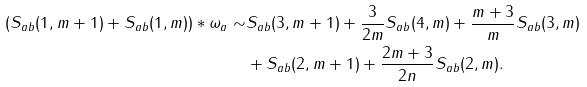<formula> <loc_0><loc_0><loc_500><loc_500>\left ( S _ { a b } ( 1 , m + 1 ) + S _ { a b } ( 1 , m ) \right ) * \omega _ { a } \sim & S _ { a b } ( 3 , m + 1 ) + \frac { 3 } { 2 m } S _ { a b } ( 4 , m ) + \frac { m + 3 } { m } S _ { a b } ( 3 , m ) \\ & + S _ { a b } ( 2 , m + 1 ) + \frac { 2 m + 3 } { 2 n } S _ { a b } ( 2 , m ) .</formula> 